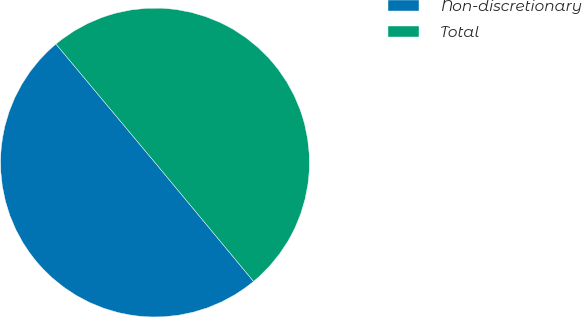Convert chart to OTSL. <chart><loc_0><loc_0><loc_500><loc_500><pie_chart><fcel>Non-discretionary<fcel>Total<nl><fcel>49.94%<fcel>50.06%<nl></chart> 